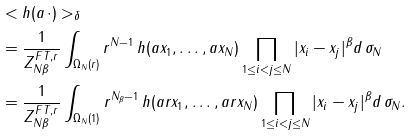<formula> <loc_0><loc_0><loc_500><loc_500>& < h ( a \, \cdot ) > _ { \delta } \\ & = \frac { 1 } { Z _ { N \beta } ^ { F T , r } } \int _ { \Omega _ { N } ( r ) } r ^ { N - 1 } \, h ( a x _ { 1 } , \dots , a x _ { N } ) \prod _ { 1 \leq i < j \leq N } | x _ { i } - x _ { j } | ^ { \beta } d \, \sigma _ { N } \\ & = \frac { 1 } { Z _ { N \beta } ^ { F T , r } } \int _ { \Omega _ { N } ( 1 ) } r ^ { N _ { \beta } - 1 } \, h ( a r x _ { 1 } , \dots , a r x _ { N } ) \prod _ { 1 \leq i < j \leq N } | x _ { i } - x _ { j } | ^ { \beta } d \, \sigma _ { N } .</formula> 